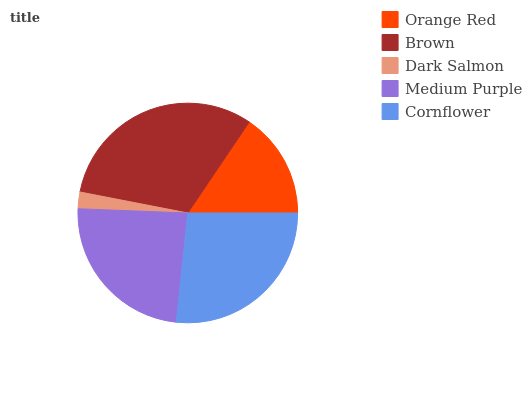Is Dark Salmon the minimum?
Answer yes or no. Yes. Is Brown the maximum?
Answer yes or no. Yes. Is Brown the minimum?
Answer yes or no. No. Is Dark Salmon the maximum?
Answer yes or no. No. Is Brown greater than Dark Salmon?
Answer yes or no. Yes. Is Dark Salmon less than Brown?
Answer yes or no. Yes. Is Dark Salmon greater than Brown?
Answer yes or no. No. Is Brown less than Dark Salmon?
Answer yes or no. No. Is Medium Purple the high median?
Answer yes or no. Yes. Is Medium Purple the low median?
Answer yes or no. Yes. Is Cornflower the high median?
Answer yes or no. No. Is Brown the low median?
Answer yes or no. No. 